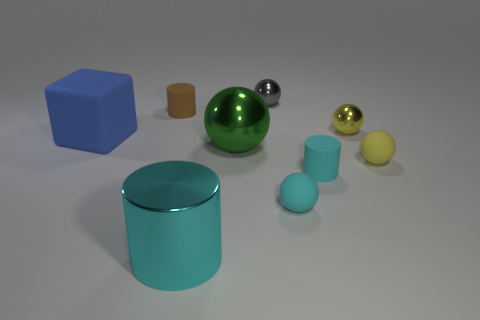Add 1 rubber cylinders. How many objects exist? 10 Subtract all cyan matte spheres. How many spheres are left? 4 Subtract all brown cylinders. How many cylinders are left? 2 Subtract 3 cylinders. How many cylinders are left? 0 Subtract all purple spheres. How many cyan cylinders are left? 2 Subtract all balls. How many objects are left? 4 Add 5 yellow metallic things. How many yellow metallic things are left? 6 Add 8 blue rubber objects. How many blue rubber objects exist? 9 Subtract 0 green blocks. How many objects are left? 9 Subtract all blue cylinders. Subtract all cyan balls. How many cylinders are left? 3 